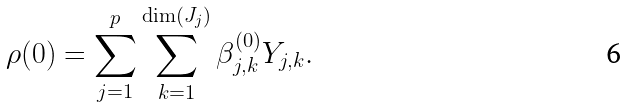<formula> <loc_0><loc_0><loc_500><loc_500>\rho ( 0 ) = \sum _ { j = 1 } ^ { p } \sum _ { k = 1 } ^ { \dim ( J _ { j } ) } \beta _ { j , k } ^ { ( 0 ) } Y _ { j , k } .</formula> 